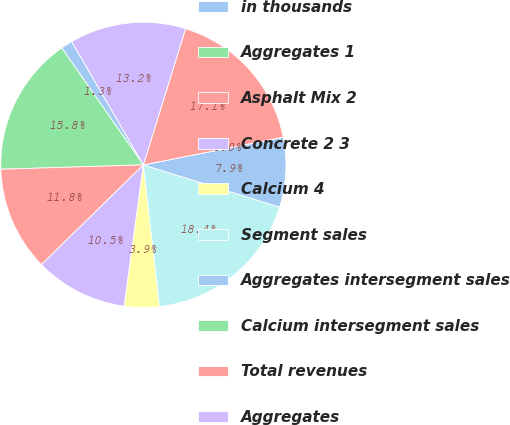Convert chart to OTSL. <chart><loc_0><loc_0><loc_500><loc_500><pie_chart><fcel>in thousands<fcel>Aggregates 1<fcel>Asphalt Mix 2<fcel>Concrete 2 3<fcel>Calcium 4<fcel>Segment sales<fcel>Aggregates intersegment sales<fcel>Calcium intersegment sales<fcel>Total revenues<fcel>Aggregates<nl><fcel>1.32%<fcel>15.79%<fcel>11.84%<fcel>10.53%<fcel>3.95%<fcel>18.42%<fcel>7.89%<fcel>0.0%<fcel>17.11%<fcel>13.16%<nl></chart> 